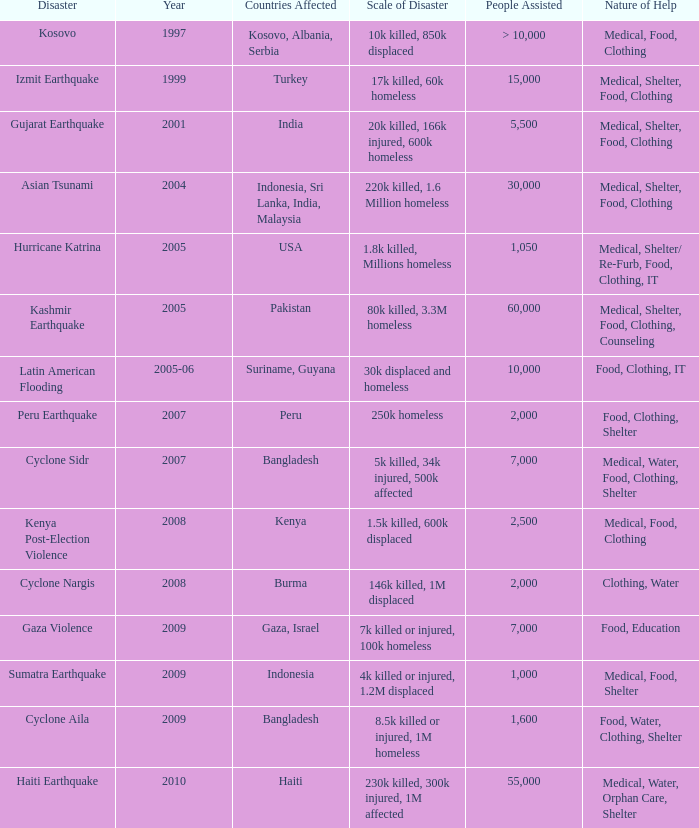Parse the table in full. {'header': ['Disaster', 'Year', 'Countries Affected', 'Scale of Disaster', 'People Assisted', 'Nature of Help'], 'rows': [['Kosovo', '1997', 'Kosovo, Albania, Serbia', '10k killed, 850k displaced', '> 10,000', 'Medical, Food, Clothing'], ['Izmit Earthquake', '1999', 'Turkey', '17k killed, 60k homeless', '15,000', 'Medical, Shelter, Food, Clothing'], ['Gujarat Earthquake', '2001', 'India', '20k killed, 166k injured, 600k homeless', '5,500', 'Medical, Shelter, Food, Clothing'], ['Asian Tsunami', '2004', 'Indonesia, Sri Lanka, India, Malaysia', '220k killed, 1.6 Million homeless', '30,000', 'Medical, Shelter, Food, Clothing'], ['Hurricane Katrina', '2005', 'USA', '1.8k killed, Millions homeless', '1,050', 'Medical, Shelter/ Re-Furb, Food, Clothing, IT'], ['Kashmir Earthquake', '2005', 'Pakistan', '80k killed, 3.3M homeless', '60,000', 'Medical, Shelter, Food, Clothing, Counseling'], ['Latin American Flooding', '2005-06', 'Suriname, Guyana', '30k displaced and homeless', '10,000', 'Food, Clothing, IT'], ['Peru Earthquake', '2007', 'Peru', '250k homeless', '2,000', 'Food, Clothing, Shelter'], ['Cyclone Sidr', '2007', 'Bangladesh', '5k killed, 34k injured, 500k affected', '7,000', 'Medical, Water, Food, Clothing, Shelter'], ['Kenya Post-Election Violence', '2008', 'Kenya', '1.5k killed, 600k displaced', '2,500', 'Medical, Food, Clothing'], ['Cyclone Nargis', '2008', 'Burma', '146k killed, 1M displaced', '2,000', 'Clothing, Water'], ['Gaza Violence', '2009', 'Gaza, Israel', '7k killed or injured, 100k homeless', '7,000', 'Food, Education'], ['Sumatra Earthquake', '2009', 'Indonesia', '4k killed or injured, 1.2M displaced', '1,000', 'Medical, Food, Shelter'], ['Cyclone Aila', '2009', 'Bangladesh', '8.5k killed or injured, 1M homeless', '1,600', 'Food, Water, Clothing, Shelter'], ['Haiti Earthquake', '2010', 'Haiti', '230k killed, 300k injured, 1M affected', '55,000', 'Medical, Water, Orphan Care, Shelter']]} In the disaster in which 1,000 people were helped, what was the nature of help? Medical, Food, Shelter. 